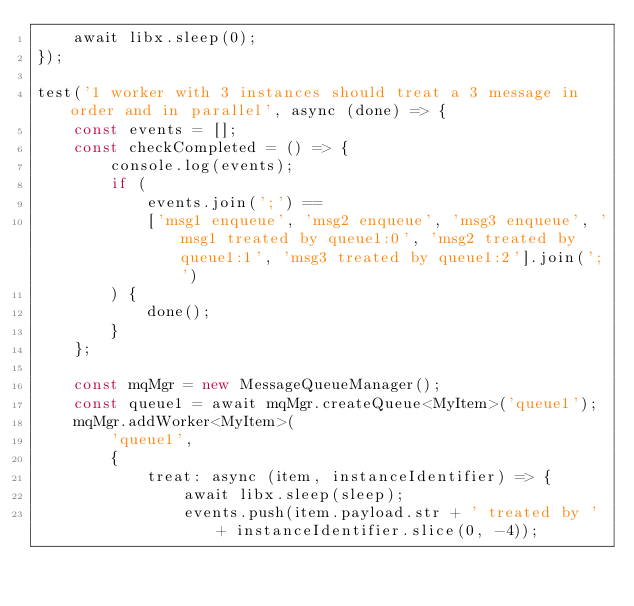Convert code to text. <code><loc_0><loc_0><loc_500><loc_500><_TypeScript_>    await libx.sleep(0);
});

test('1 worker with 3 instances should treat a 3 message in order and in parallel', async (done) => {
    const events = [];
    const checkCompleted = () => {
        console.log(events);
        if (
            events.join(';') ==
            ['msg1 enqueue', 'msg2 enqueue', 'msg3 enqueue', 'msg1 treated by queue1:0', 'msg2 treated by queue1:1', 'msg3 treated by queue1:2'].join(';')
        ) {
            done();
        }
    };

    const mqMgr = new MessageQueueManager();
    const queue1 = await mqMgr.createQueue<MyItem>('queue1');
    mqMgr.addWorker<MyItem>(
        'queue1',
        {
            treat: async (item, instanceIdentifier) => {
                await libx.sleep(sleep);
                events.push(item.payload.str + ' treated by ' + instanceIdentifier.slice(0, -4));</code> 